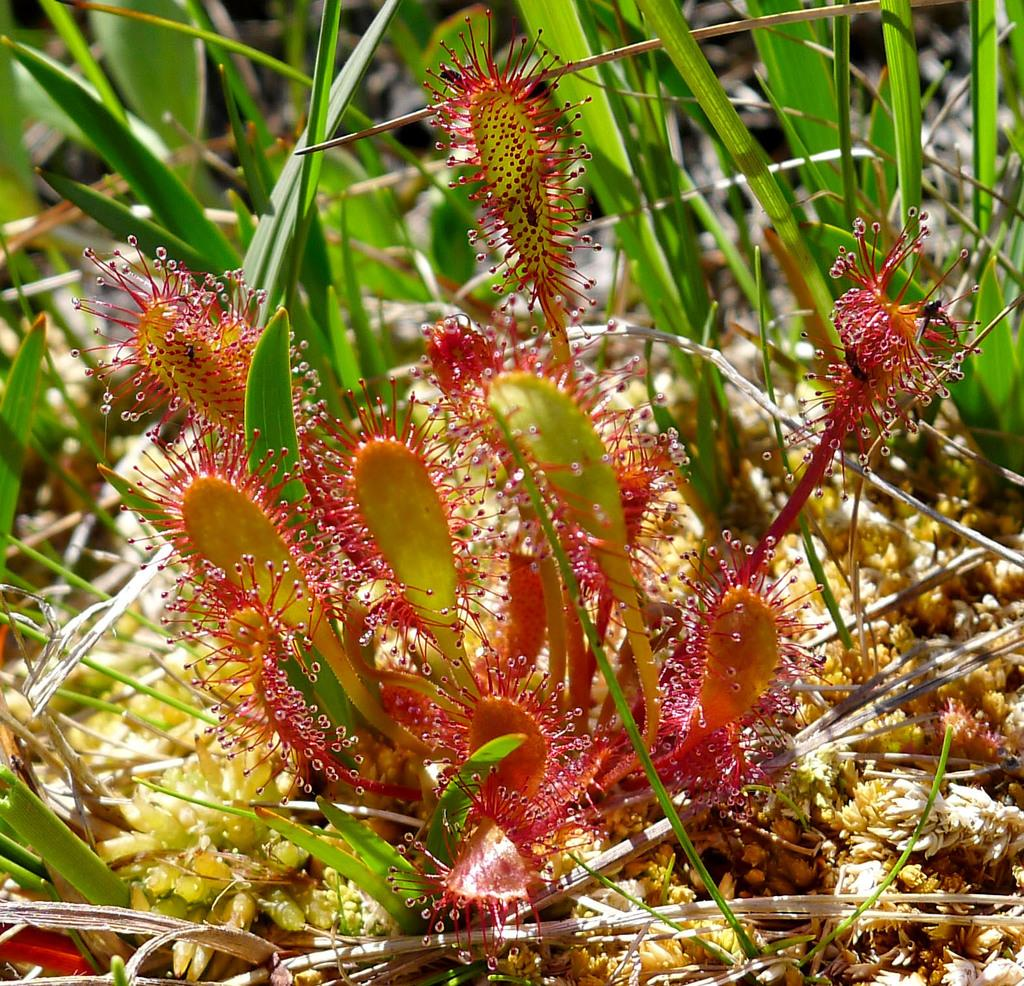What is present in the image related to vegetation? There is a plant in the image. Can you describe any specific features of the plant? There are leaves in the image. What type of pollution can be seen in the image? There is no pollution present in the image; it only features a plant with leaves. What activity is taking place in the image? The image does not depict any specific activity; it simply shows a plant with leaves. 